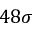<formula> <loc_0><loc_0><loc_500><loc_500>4 8 \sigma</formula> 